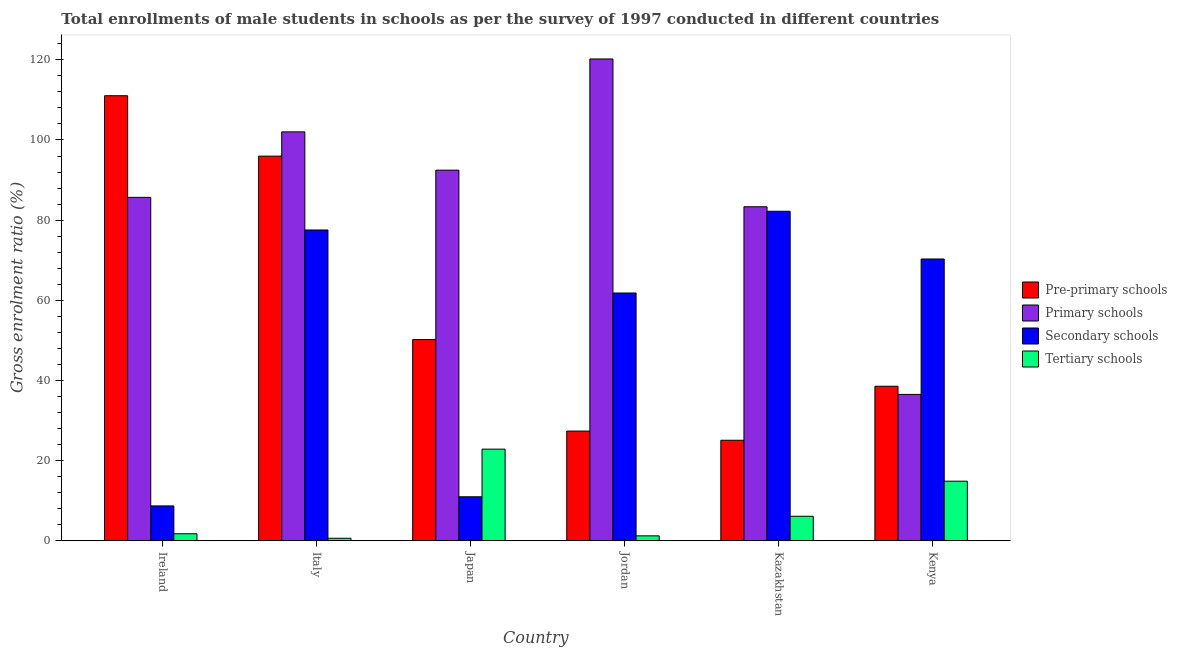How many different coloured bars are there?
Make the answer very short. 4. Are the number of bars on each tick of the X-axis equal?
Keep it short and to the point. Yes. How many bars are there on the 5th tick from the right?
Keep it short and to the point. 4. What is the label of the 2nd group of bars from the left?
Ensure brevity in your answer.  Italy. What is the gross enrolment ratio(male) in pre-primary schools in Italy?
Your answer should be compact. 95.97. Across all countries, what is the maximum gross enrolment ratio(male) in pre-primary schools?
Provide a short and direct response. 111.05. Across all countries, what is the minimum gross enrolment ratio(male) in secondary schools?
Ensure brevity in your answer.  8.69. In which country was the gross enrolment ratio(male) in primary schools maximum?
Provide a succinct answer. Jordan. What is the total gross enrolment ratio(male) in tertiary schools in the graph?
Keep it short and to the point. 47.38. What is the difference between the gross enrolment ratio(male) in primary schools in Japan and that in Kenya?
Offer a terse response. 55.96. What is the difference between the gross enrolment ratio(male) in primary schools in Kenya and the gross enrolment ratio(male) in tertiary schools in Kazakhstan?
Offer a very short reply. 30.41. What is the average gross enrolment ratio(male) in tertiary schools per country?
Your answer should be compact. 7.9. What is the difference between the gross enrolment ratio(male) in primary schools and gross enrolment ratio(male) in tertiary schools in Italy?
Keep it short and to the point. 101.41. In how many countries, is the gross enrolment ratio(male) in pre-primary schools greater than 84 %?
Give a very brief answer. 2. What is the ratio of the gross enrolment ratio(male) in primary schools in Japan to that in Jordan?
Provide a short and direct response. 0.77. Is the gross enrolment ratio(male) in pre-primary schools in Italy less than that in Kenya?
Keep it short and to the point. No. What is the difference between the highest and the second highest gross enrolment ratio(male) in tertiary schools?
Your answer should be compact. 8. What is the difference between the highest and the lowest gross enrolment ratio(male) in secondary schools?
Ensure brevity in your answer.  73.53. In how many countries, is the gross enrolment ratio(male) in primary schools greater than the average gross enrolment ratio(male) in primary schools taken over all countries?
Provide a short and direct response. 3. Is it the case that in every country, the sum of the gross enrolment ratio(male) in tertiary schools and gross enrolment ratio(male) in pre-primary schools is greater than the sum of gross enrolment ratio(male) in secondary schools and gross enrolment ratio(male) in primary schools?
Offer a terse response. No. What does the 2nd bar from the left in Kenya represents?
Ensure brevity in your answer.  Primary schools. What does the 2nd bar from the right in Japan represents?
Provide a succinct answer. Secondary schools. Are the values on the major ticks of Y-axis written in scientific E-notation?
Give a very brief answer. No. Does the graph contain any zero values?
Give a very brief answer. No. Does the graph contain grids?
Provide a succinct answer. No. What is the title of the graph?
Offer a very short reply. Total enrollments of male students in schools as per the survey of 1997 conducted in different countries. Does "Burnt food" appear as one of the legend labels in the graph?
Make the answer very short. No. What is the label or title of the X-axis?
Your answer should be very brief. Country. What is the Gross enrolment ratio (%) in Pre-primary schools in Ireland?
Offer a very short reply. 111.05. What is the Gross enrolment ratio (%) of Primary schools in Ireland?
Your answer should be very brief. 85.69. What is the Gross enrolment ratio (%) in Secondary schools in Ireland?
Provide a short and direct response. 8.69. What is the Gross enrolment ratio (%) of Tertiary schools in Ireland?
Make the answer very short. 1.74. What is the Gross enrolment ratio (%) of Pre-primary schools in Italy?
Ensure brevity in your answer.  95.97. What is the Gross enrolment ratio (%) of Primary schools in Italy?
Keep it short and to the point. 102.03. What is the Gross enrolment ratio (%) in Secondary schools in Italy?
Your response must be concise. 77.54. What is the Gross enrolment ratio (%) of Tertiary schools in Italy?
Your answer should be compact. 0.61. What is the Gross enrolment ratio (%) of Pre-primary schools in Japan?
Provide a succinct answer. 50.19. What is the Gross enrolment ratio (%) of Primary schools in Japan?
Ensure brevity in your answer.  92.47. What is the Gross enrolment ratio (%) of Secondary schools in Japan?
Your answer should be very brief. 10.97. What is the Gross enrolment ratio (%) of Tertiary schools in Japan?
Provide a succinct answer. 22.86. What is the Gross enrolment ratio (%) of Pre-primary schools in Jordan?
Keep it short and to the point. 27.36. What is the Gross enrolment ratio (%) in Primary schools in Jordan?
Provide a succinct answer. 120.22. What is the Gross enrolment ratio (%) in Secondary schools in Jordan?
Offer a terse response. 61.82. What is the Gross enrolment ratio (%) in Tertiary schools in Jordan?
Your answer should be compact. 1.21. What is the Gross enrolment ratio (%) in Pre-primary schools in Kazakhstan?
Offer a terse response. 25.07. What is the Gross enrolment ratio (%) of Primary schools in Kazakhstan?
Offer a terse response. 83.34. What is the Gross enrolment ratio (%) in Secondary schools in Kazakhstan?
Offer a very short reply. 82.22. What is the Gross enrolment ratio (%) of Tertiary schools in Kazakhstan?
Your answer should be very brief. 6.1. What is the Gross enrolment ratio (%) in Pre-primary schools in Kenya?
Your response must be concise. 38.55. What is the Gross enrolment ratio (%) of Primary schools in Kenya?
Your answer should be compact. 36.51. What is the Gross enrolment ratio (%) in Secondary schools in Kenya?
Provide a succinct answer. 70.31. What is the Gross enrolment ratio (%) of Tertiary schools in Kenya?
Keep it short and to the point. 14.85. Across all countries, what is the maximum Gross enrolment ratio (%) in Pre-primary schools?
Your answer should be compact. 111.05. Across all countries, what is the maximum Gross enrolment ratio (%) in Primary schools?
Make the answer very short. 120.22. Across all countries, what is the maximum Gross enrolment ratio (%) of Secondary schools?
Your answer should be very brief. 82.22. Across all countries, what is the maximum Gross enrolment ratio (%) in Tertiary schools?
Keep it short and to the point. 22.86. Across all countries, what is the minimum Gross enrolment ratio (%) in Pre-primary schools?
Offer a terse response. 25.07. Across all countries, what is the minimum Gross enrolment ratio (%) of Primary schools?
Give a very brief answer. 36.51. Across all countries, what is the minimum Gross enrolment ratio (%) of Secondary schools?
Provide a short and direct response. 8.69. Across all countries, what is the minimum Gross enrolment ratio (%) in Tertiary schools?
Your answer should be compact. 0.61. What is the total Gross enrolment ratio (%) of Pre-primary schools in the graph?
Provide a succinct answer. 348.2. What is the total Gross enrolment ratio (%) in Primary schools in the graph?
Provide a succinct answer. 520.26. What is the total Gross enrolment ratio (%) in Secondary schools in the graph?
Provide a succinct answer. 311.54. What is the total Gross enrolment ratio (%) of Tertiary schools in the graph?
Offer a very short reply. 47.38. What is the difference between the Gross enrolment ratio (%) of Pre-primary schools in Ireland and that in Italy?
Keep it short and to the point. 15.08. What is the difference between the Gross enrolment ratio (%) of Primary schools in Ireland and that in Italy?
Provide a short and direct response. -16.34. What is the difference between the Gross enrolment ratio (%) of Secondary schools in Ireland and that in Italy?
Keep it short and to the point. -68.86. What is the difference between the Gross enrolment ratio (%) in Tertiary schools in Ireland and that in Italy?
Give a very brief answer. 1.13. What is the difference between the Gross enrolment ratio (%) in Pre-primary schools in Ireland and that in Japan?
Provide a short and direct response. 60.86. What is the difference between the Gross enrolment ratio (%) in Primary schools in Ireland and that in Japan?
Give a very brief answer. -6.79. What is the difference between the Gross enrolment ratio (%) of Secondary schools in Ireland and that in Japan?
Keep it short and to the point. -2.28. What is the difference between the Gross enrolment ratio (%) of Tertiary schools in Ireland and that in Japan?
Ensure brevity in your answer.  -21.12. What is the difference between the Gross enrolment ratio (%) in Pre-primary schools in Ireland and that in Jordan?
Offer a terse response. 83.68. What is the difference between the Gross enrolment ratio (%) in Primary schools in Ireland and that in Jordan?
Your answer should be compact. -34.53. What is the difference between the Gross enrolment ratio (%) in Secondary schools in Ireland and that in Jordan?
Provide a succinct answer. -53.13. What is the difference between the Gross enrolment ratio (%) of Tertiary schools in Ireland and that in Jordan?
Provide a short and direct response. 0.53. What is the difference between the Gross enrolment ratio (%) in Pre-primary schools in Ireland and that in Kazakhstan?
Your response must be concise. 85.98. What is the difference between the Gross enrolment ratio (%) of Primary schools in Ireland and that in Kazakhstan?
Your answer should be very brief. 2.35. What is the difference between the Gross enrolment ratio (%) in Secondary schools in Ireland and that in Kazakhstan?
Make the answer very short. -73.53. What is the difference between the Gross enrolment ratio (%) of Tertiary schools in Ireland and that in Kazakhstan?
Give a very brief answer. -4.36. What is the difference between the Gross enrolment ratio (%) of Pre-primary schools in Ireland and that in Kenya?
Provide a short and direct response. 72.5. What is the difference between the Gross enrolment ratio (%) of Primary schools in Ireland and that in Kenya?
Ensure brevity in your answer.  49.18. What is the difference between the Gross enrolment ratio (%) in Secondary schools in Ireland and that in Kenya?
Ensure brevity in your answer.  -61.62. What is the difference between the Gross enrolment ratio (%) in Tertiary schools in Ireland and that in Kenya?
Your response must be concise. -13.11. What is the difference between the Gross enrolment ratio (%) in Pre-primary schools in Italy and that in Japan?
Offer a very short reply. 45.78. What is the difference between the Gross enrolment ratio (%) in Primary schools in Italy and that in Japan?
Give a very brief answer. 9.55. What is the difference between the Gross enrolment ratio (%) of Secondary schools in Italy and that in Japan?
Keep it short and to the point. 66.58. What is the difference between the Gross enrolment ratio (%) of Tertiary schools in Italy and that in Japan?
Offer a terse response. -22.24. What is the difference between the Gross enrolment ratio (%) in Pre-primary schools in Italy and that in Jordan?
Make the answer very short. 68.61. What is the difference between the Gross enrolment ratio (%) of Primary schools in Italy and that in Jordan?
Provide a succinct answer. -18.19. What is the difference between the Gross enrolment ratio (%) of Secondary schools in Italy and that in Jordan?
Offer a terse response. 15.73. What is the difference between the Gross enrolment ratio (%) in Tertiary schools in Italy and that in Jordan?
Ensure brevity in your answer.  -0.6. What is the difference between the Gross enrolment ratio (%) of Pre-primary schools in Italy and that in Kazakhstan?
Keep it short and to the point. 70.9. What is the difference between the Gross enrolment ratio (%) of Primary schools in Italy and that in Kazakhstan?
Ensure brevity in your answer.  18.69. What is the difference between the Gross enrolment ratio (%) in Secondary schools in Italy and that in Kazakhstan?
Keep it short and to the point. -4.67. What is the difference between the Gross enrolment ratio (%) in Tertiary schools in Italy and that in Kazakhstan?
Keep it short and to the point. -5.49. What is the difference between the Gross enrolment ratio (%) in Pre-primary schools in Italy and that in Kenya?
Keep it short and to the point. 57.42. What is the difference between the Gross enrolment ratio (%) of Primary schools in Italy and that in Kenya?
Ensure brevity in your answer.  65.52. What is the difference between the Gross enrolment ratio (%) of Secondary schools in Italy and that in Kenya?
Your answer should be very brief. 7.24. What is the difference between the Gross enrolment ratio (%) in Tertiary schools in Italy and that in Kenya?
Make the answer very short. -14.24. What is the difference between the Gross enrolment ratio (%) in Pre-primary schools in Japan and that in Jordan?
Provide a short and direct response. 22.83. What is the difference between the Gross enrolment ratio (%) of Primary schools in Japan and that in Jordan?
Offer a very short reply. -27.75. What is the difference between the Gross enrolment ratio (%) of Secondary schools in Japan and that in Jordan?
Your answer should be compact. -50.85. What is the difference between the Gross enrolment ratio (%) of Tertiary schools in Japan and that in Jordan?
Offer a terse response. 21.64. What is the difference between the Gross enrolment ratio (%) of Pre-primary schools in Japan and that in Kazakhstan?
Give a very brief answer. 25.12. What is the difference between the Gross enrolment ratio (%) of Primary schools in Japan and that in Kazakhstan?
Your answer should be very brief. 9.13. What is the difference between the Gross enrolment ratio (%) in Secondary schools in Japan and that in Kazakhstan?
Provide a short and direct response. -71.25. What is the difference between the Gross enrolment ratio (%) of Tertiary schools in Japan and that in Kazakhstan?
Your answer should be very brief. 16.75. What is the difference between the Gross enrolment ratio (%) of Pre-primary schools in Japan and that in Kenya?
Make the answer very short. 11.64. What is the difference between the Gross enrolment ratio (%) in Primary schools in Japan and that in Kenya?
Provide a short and direct response. 55.96. What is the difference between the Gross enrolment ratio (%) of Secondary schools in Japan and that in Kenya?
Your response must be concise. -59.34. What is the difference between the Gross enrolment ratio (%) of Tertiary schools in Japan and that in Kenya?
Your answer should be compact. 8. What is the difference between the Gross enrolment ratio (%) of Pre-primary schools in Jordan and that in Kazakhstan?
Your response must be concise. 2.29. What is the difference between the Gross enrolment ratio (%) in Primary schools in Jordan and that in Kazakhstan?
Your response must be concise. 36.88. What is the difference between the Gross enrolment ratio (%) in Secondary schools in Jordan and that in Kazakhstan?
Keep it short and to the point. -20.4. What is the difference between the Gross enrolment ratio (%) in Tertiary schools in Jordan and that in Kazakhstan?
Your answer should be very brief. -4.89. What is the difference between the Gross enrolment ratio (%) in Pre-primary schools in Jordan and that in Kenya?
Provide a short and direct response. -11.18. What is the difference between the Gross enrolment ratio (%) of Primary schools in Jordan and that in Kenya?
Provide a short and direct response. 83.71. What is the difference between the Gross enrolment ratio (%) in Secondary schools in Jordan and that in Kenya?
Provide a succinct answer. -8.49. What is the difference between the Gross enrolment ratio (%) in Tertiary schools in Jordan and that in Kenya?
Give a very brief answer. -13.64. What is the difference between the Gross enrolment ratio (%) in Pre-primary schools in Kazakhstan and that in Kenya?
Provide a succinct answer. -13.48. What is the difference between the Gross enrolment ratio (%) in Primary schools in Kazakhstan and that in Kenya?
Provide a succinct answer. 46.83. What is the difference between the Gross enrolment ratio (%) in Secondary schools in Kazakhstan and that in Kenya?
Offer a very short reply. 11.91. What is the difference between the Gross enrolment ratio (%) in Tertiary schools in Kazakhstan and that in Kenya?
Provide a short and direct response. -8.75. What is the difference between the Gross enrolment ratio (%) in Pre-primary schools in Ireland and the Gross enrolment ratio (%) in Primary schools in Italy?
Your answer should be very brief. 9.02. What is the difference between the Gross enrolment ratio (%) of Pre-primary schools in Ireland and the Gross enrolment ratio (%) of Secondary schools in Italy?
Keep it short and to the point. 33.51. What is the difference between the Gross enrolment ratio (%) of Pre-primary schools in Ireland and the Gross enrolment ratio (%) of Tertiary schools in Italy?
Offer a terse response. 110.44. What is the difference between the Gross enrolment ratio (%) of Primary schools in Ireland and the Gross enrolment ratio (%) of Secondary schools in Italy?
Provide a succinct answer. 8.14. What is the difference between the Gross enrolment ratio (%) of Primary schools in Ireland and the Gross enrolment ratio (%) of Tertiary schools in Italy?
Your response must be concise. 85.07. What is the difference between the Gross enrolment ratio (%) of Secondary schools in Ireland and the Gross enrolment ratio (%) of Tertiary schools in Italy?
Ensure brevity in your answer.  8.07. What is the difference between the Gross enrolment ratio (%) in Pre-primary schools in Ireland and the Gross enrolment ratio (%) in Primary schools in Japan?
Your response must be concise. 18.58. What is the difference between the Gross enrolment ratio (%) in Pre-primary schools in Ireland and the Gross enrolment ratio (%) in Secondary schools in Japan?
Ensure brevity in your answer.  100.08. What is the difference between the Gross enrolment ratio (%) of Pre-primary schools in Ireland and the Gross enrolment ratio (%) of Tertiary schools in Japan?
Your answer should be very brief. 88.19. What is the difference between the Gross enrolment ratio (%) in Primary schools in Ireland and the Gross enrolment ratio (%) in Secondary schools in Japan?
Make the answer very short. 74.72. What is the difference between the Gross enrolment ratio (%) in Primary schools in Ireland and the Gross enrolment ratio (%) in Tertiary schools in Japan?
Your response must be concise. 62.83. What is the difference between the Gross enrolment ratio (%) in Secondary schools in Ireland and the Gross enrolment ratio (%) in Tertiary schools in Japan?
Provide a short and direct response. -14.17. What is the difference between the Gross enrolment ratio (%) of Pre-primary schools in Ireland and the Gross enrolment ratio (%) of Primary schools in Jordan?
Provide a succinct answer. -9.17. What is the difference between the Gross enrolment ratio (%) in Pre-primary schools in Ireland and the Gross enrolment ratio (%) in Secondary schools in Jordan?
Provide a short and direct response. 49.23. What is the difference between the Gross enrolment ratio (%) of Pre-primary schools in Ireland and the Gross enrolment ratio (%) of Tertiary schools in Jordan?
Make the answer very short. 109.83. What is the difference between the Gross enrolment ratio (%) of Primary schools in Ireland and the Gross enrolment ratio (%) of Secondary schools in Jordan?
Provide a succinct answer. 23.87. What is the difference between the Gross enrolment ratio (%) in Primary schools in Ireland and the Gross enrolment ratio (%) in Tertiary schools in Jordan?
Make the answer very short. 84.47. What is the difference between the Gross enrolment ratio (%) in Secondary schools in Ireland and the Gross enrolment ratio (%) in Tertiary schools in Jordan?
Provide a short and direct response. 7.47. What is the difference between the Gross enrolment ratio (%) in Pre-primary schools in Ireland and the Gross enrolment ratio (%) in Primary schools in Kazakhstan?
Provide a succinct answer. 27.71. What is the difference between the Gross enrolment ratio (%) in Pre-primary schools in Ireland and the Gross enrolment ratio (%) in Secondary schools in Kazakhstan?
Provide a short and direct response. 28.83. What is the difference between the Gross enrolment ratio (%) in Pre-primary schools in Ireland and the Gross enrolment ratio (%) in Tertiary schools in Kazakhstan?
Offer a terse response. 104.95. What is the difference between the Gross enrolment ratio (%) in Primary schools in Ireland and the Gross enrolment ratio (%) in Secondary schools in Kazakhstan?
Your answer should be compact. 3.47. What is the difference between the Gross enrolment ratio (%) of Primary schools in Ireland and the Gross enrolment ratio (%) of Tertiary schools in Kazakhstan?
Provide a succinct answer. 79.58. What is the difference between the Gross enrolment ratio (%) of Secondary schools in Ireland and the Gross enrolment ratio (%) of Tertiary schools in Kazakhstan?
Give a very brief answer. 2.58. What is the difference between the Gross enrolment ratio (%) of Pre-primary schools in Ireland and the Gross enrolment ratio (%) of Primary schools in Kenya?
Offer a terse response. 74.54. What is the difference between the Gross enrolment ratio (%) of Pre-primary schools in Ireland and the Gross enrolment ratio (%) of Secondary schools in Kenya?
Keep it short and to the point. 40.74. What is the difference between the Gross enrolment ratio (%) of Pre-primary schools in Ireland and the Gross enrolment ratio (%) of Tertiary schools in Kenya?
Keep it short and to the point. 96.2. What is the difference between the Gross enrolment ratio (%) of Primary schools in Ireland and the Gross enrolment ratio (%) of Secondary schools in Kenya?
Give a very brief answer. 15.38. What is the difference between the Gross enrolment ratio (%) in Primary schools in Ireland and the Gross enrolment ratio (%) in Tertiary schools in Kenya?
Ensure brevity in your answer.  70.84. What is the difference between the Gross enrolment ratio (%) of Secondary schools in Ireland and the Gross enrolment ratio (%) of Tertiary schools in Kenya?
Your answer should be compact. -6.17. What is the difference between the Gross enrolment ratio (%) in Pre-primary schools in Italy and the Gross enrolment ratio (%) in Primary schools in Japan?
Offer a very short reply. 3.5. What is the difference between the Gross enrolment ratio (%) of Pre-primary schools in Italy and the Gross enrolment ratio (%) of Secondary schools in Japan?
Keep it short and to the point. 85.01. What is the difference between the Gross enrolment ratio (%) of Pre-primary schools in Italy and the Gross enrolment ratio (%) of Tertiary schools in Japan?
Provide a succinct answer. 73.12. What is the difference between the Gross enrolment ratio (%) in Primary schools in Italy and the Gross enrolment ratio (%) in Secondary schools in Japan?
Give a very brief answer. 91.06. What is the difference between the Gross enrolment ratio (%) of Primary schools in Italy and the Gross enrolment ratio (%) of Tertiary schools in Japan?
Offer a very short reply. 79.17. What is the difference between the Gross enrolment ratio (%) in Secondary schools in Italy and the Gross enrolment ratio (%) in Tertiary schools in Japan?
Offer a terse response. 54.69. What is the difference between the Gross enrolment ratio (%) in Pre-primary schools in Italy and the Gross enrolment ratio (%) in Primary schools in Jordan?
Ensure brevity in your answer.  -24.25. What is the difference between the Gross enrolment ratio (%) of Pre-primary schools in Italy and the Gross enrolment ratio (%) of Secondary schools in Jordan?
Keep it short and to the point. 34.16. What is the difference between the Gross enrolment ratio (%) in Pre-primary schools in Italy and the Gross enrolment ratio (%) in Tertiary schools in Jordan?
Give a very brief answer. 94.76. What is the difference between the Gross enrolment ratio (%) of Primary schools in Italy and the Gross enrolment ratio (%) of Secondary schools in Jordan?
Offer a very short reply. 40.21. What is the difference between the Gross enrolment ratio (%) of Primary schools in Italy and the Gross enrolment ratio (%) of Tertiary schools in Jordan?
Make the answer very short. 100.81. What is the difference between the Gross enrolment ratio (%) of Secondary schools in Italy and the Gross enrolment ratio (%) of Tertiary schools in Jordan?
Your response must be concise. 76.33. What is the difference between the Gross enrolment ratio (%) of Pre-primary schools in Italy and the Gross enrolment ratio (%) of Primary schools in Kazakhstan?
Give a very brief answer. 12.63. What is the difference between the Gross enrolment ratio (%) of Pre-primary schools in Italy and the Gross enrolment ratio (%) of Secondary schools in Kazakhstan?
Your response must be concise. 13.76. What is the difference between the Gross enrolment ratio (%) in Pre-primary schools in Italy and the Gross enrolment ratio (%) in Tertiary schools in Kazakhstan?
Provide a succinct answer. 89.87. What is the difference between the Gross enrolment ratio (%) of Primary schools in Italy and the Gross enrolment ratio (%) of Secondary schools in Kazakhstan?
Provide a short and direct response. 19.81. What is the difference between the Gross enrolment ratio (%) in Primary schools in Italy and the Gross enrolment ratio (%) in Tertiary schools in Kazakhstan?
Give a very brief answer. 95.92. What is the difference between the Gross enrolment ratio (%) of Secondary schools in Italy and the Gross enrolment ratio (%) of Tertiary schools in Kazakhstan?
Make the answer very short. 71.44. What is the difference between the Gross enrolment ratio (%) in Pre-primary schools in Italy and the Gross enrolment ratio (%) in Primary schools in Kenya?
Offer a terse response. 59.46. What is the difference between the Gross enrolment ratio (%) in Pre-primary schools in Italy and the Gross enrolment ratio (%) in Secondary schools in Kenya?
Keep it short and to the point. 25.67. What is the difference between the Gross enrolment ratio (%) in Pre-primary schools in Italy and the Gross enrolment ratio (%) in Tertiary schools in Kenya?
Offer a very short reply. 81.12. What is the difference between the Gross enrolment ratio (%) of Primary schools in Italy and the Gross enrolment ratio (%) of Secondary schools in Kenya?
Offer a very short reply. 31.72. What is the difference between the Gross enrolment ratio (%) of Primary schools in Italy and the Gross enrolment ratio (%) of Tertiary schools in Kenya?
Keep it short and to the point. 87.18. What is the difference between the Gross enrolment ratio (%) in Secondary schools in Italy and the Gross enrolment ratio (%) in Tertiary schools in Kenya?
Your answer should be very brief. 62.69. What is the difference between the Gross enrolment ratio (%) of Pre-primary schools in Japan and the Gross enrolment ratio (%) of Primary schools in Jordan?
Keep it short and to the point. -70.03. What is the difference between the Gross enrolment ratio (%) of Pre-primary schools in Japan and the Gross enrolment ratio (%) of Secondary schools in Jordan?
Your response must be concise. -11.62. What is the difference between the Gross enrolment ratio (%) in Pre-primary schools in Japan and the Gross enrolment ratio (%) in Tertiary schools in Jordan?
Offer a very short reply. 48.98. What is the difference between the Gross enrolment ratio (%) in Primary schools in Japan and the Gross enrolment ratio (%) in Secondary schools in Jordan?
Make the answer very short. 30.66. What is the difference between the Gross enrolment ratio (%) of Primary schools in Japan and the Gross enrolment ratio (%) of Tertiary schools in Jordan?
Provide a short and direct response. 91.26. What is the difference between the Gross enrolment ratio (%) of Secondary schools in Japan and the Gross enrolment ratio (%) of Tertiary schools in Jordan?
Offer a terse response. 9.75. What is the difference between the Gross enrolment ratio (%) of Pre-primary schools in Japan and the Gross enrolment ratio (%) of Primary schools in Kazakhstan?
Offer a terse response. -33.15. What is the difference between the Gross enrolment ratio (%) of Pre-primary schools in Japan and the Gross enrolment ratio (%) of Secondary schools in Kazakhstan?
Offer a very short reply. -32.03. What is the difference between the Gross enrolment ratio (%) in Pre-primary schools in Japan and the Gross enrolment ratio (%) in Tertiary schools in Kazakhstan?
Ensure brevity in your answer.  44.09. What is the difference between the Gross enrolment ratio (%) of Primary schools in Japan and the Gross enrolment ratio (%) of Secondary schools in Kazakhstan?
Keep it short and to the point. 10.26. What is the difference between the Gross enrolment ratio (%) of Primary schools in Japan and the Gross enrolment ratio (%) of Tertiary schools in Kazakhstan?
Make the answer very short. 86.37. What is the difference between the Gross enrolment ratio (%) in Secondary schools in Japan and the Gross enrolment ratio (%) in Tertiary schools in Kazakhstan?
Provide a short and direct response. 4.86. What is the difference between the Gross enrolment ratio (%) in Pre-primary schools in Japan and the Gross enrolment ratio (%) in Primary schools in Kenya?
Your answer should be compact. 13.68. What is the difference between the Gross enrolment ratio (%) of Pre-primary schools in Japan and the Gross enrolment ratio (%) of Secondary schools in Kenya?
Your response must be concise. -20.11. What is the difference between the Gross enrolment ratio (%) in Pre-primary schools in Japan and the Gross enrolment ratio (%) in Tertiary schools in Kenya?
Make the answer very short. 35.34. What is the difference between the Gross enrolment ratio (%) of Primary schools in Japan and the Gross enrolment ratio (%) of Secondary schools in Kenya?
Make the answer very short. 22.17. What is the difference between the Gross enrolment ratio (%) in Primary schools in Japan and the Gross enrolment ratio (%) in Tertiary schools in Kenya?
Make the answer very short. 77.62. What is the difference between the Gross enrolment ratio (%) of Secondary schools in Japan and the Gross enrolment ratio (%) of Tertiary schools in Kenya?
Your answer should be compact. -3.89. What is the difference between the Gross enrolment ratio (%) of Pre-primary schools in Jordan and the Gross enrolment ratio (%) of Primary schools in Kazakhstan?
Give a very brief answer. -55.98. What is the difference between the Gross enrolment ratio (%) of Pre-primary schools in Jordan and the Gross enrolment ratio (%) of Secondary schools in Kazakhstan?
Your response must be concise. -54.85. What is the difference between the Gross enrolment ratio (%) in Pre-primary schools in Jordan and the Gross enrolment ratio (%) in Tertiary schools in Kazakhstan?
Your answer should be very brief. 21.26. What is the difference between the Gross enrolment ratio (%) of Primary schools in Jordan and the Gross enrolment ratio (%) of Secondary schools in Kazakhstan?
Give a very brief answer. 38.01. What is the difference between the Gross enrolment ratio (%) in Primary schools in Jordan and the Gross enrolment ratio (%) in Tertiary schools in Kazakhstan?
Provide a succinct answer. 114.12. What is the difference between the Gross enrolment ratio (%) of Secondary schools in Jordan and the Gross enrolment ratio (%) of Tertiary schools in Kazakhstan?
Your answer should be compact. 55.71. What is the difference between the Gross enrolment ratio (%) of Pre-primary schools in Jordan and the Gross enrolment ratio (%) of Primary schools in Kenya?
Give a very brief answer. -9.15. What is the difference between the Gross enrolment ratio (%) of Pre-primary schools in Jordan and the Gross enrolment ratio (%) of Secondary schools in Kenya?
Give a very brief answer. -42.94. What is the difference between the Gross enrolment ratio (%) in Pre-primary schools in Jordan and the Gross enrolment ratio (%) in Tertiary schools in Kenya?
Keep it short and to the point. 12.51. What is the difference between the Gross enrolment ratio (%) of Primary schools in Jordan and the Gross enrolment ratio (%) of Secondary schools in Kenya?
Give a very brief answer. 49.92. What is the difference between the Gross enrolment ratio (%) of Primary schools in Jordan and the Gross enrolment ratio (%) of Tertiary schools in Kenya?
Offer a terse response. 105.37. What is the difference between the Gross enrolment ratio (%) of Secondary schools in Jordan and the Gross enrolment ratio (%) of Tertiary schools in Kenya?
Provide a succinct answer. 46.96. What is the difference between the Gross enrolment ratio (%) in Pre-primary schools in Kazakhstan and the Gross enrolment ratio (%) in Primary schools in Kenya?
Provide a short and direct response. -11.44. What is the difference between the Gross enrolment ratio (%) of Pre-primary schools in Kazakhstan and the Gross enrolment ratio (%) of Secondary schools in Kenya?
Make the answer very short. -45.23. What is the difference between the Gross enrolment ratio (%) of Pre-primary schools in Kazakhstan and the Gross enrolment ratio (%) of Tertiary schools in Kenya?
Keep it short and to the point. 10.22. What is the difference between the Gross enrolment ratio (%) of Primary schools in Kazakhstan and the Gross enrolment ratio (%) of Secondary schools in Kenya?
Ensure brevity in your answer.  13.04. What is the difference between the Gross enrolment ratio (%) of Primary schools in Kazakhstan and the Gross enrolment ratio (%) of Tertiary schools in Kenya?
Provide a succinct answer. 68.49. What is the difference between the Gross enrolment ratio (%) of Secondary schools in Kazakhstan and the Gross enrolment ratio (%) of Tertiary schools in Kenya?
Your response must be concise. 67.36. What is the average Gross enrolment ratio (%) of Pre-primary schools per country?
Ensure brevity in your answer.  58.03. What is the average Gross enrolment ratio (%) in Primary schools per country?
Give a very brief answer. 86.71. What is the average Gross enrolment ratio (%) of Secondary schools per country?
Ensure brevity in your answer.  51.92. What is the average Gross enrolment ratio (%) of Tertiary schools per country?
Your response must be concise. 7.9. What is the difference between the Gross enrolment ratio (%) in Pre-primary schools and Gross enrolment ratio (%) in Primary schools in Ireland?
Give a very brief answer. 25.36. What is the difference between the Gross enrolment ratio (%) in Pre-primary schools and Gross enrolment ratio (%) in Secondary schools in Ireland?
Make the answer very short. 102.36. What is the difference between the Gross enrolment ratio (%) in Pre-primary schools and Gross enrolment ratio (%) in Tertiary schools in Ireland?
Make the answer very short. 109.31. What is the difference between the Gross enrolment ratio (%) in Primary schools and Gross enrolment ratio (%) in Secondary schools in Ireland?
Make the answer very short. 77. What is the difference between the Gross enrolment ratio (%) in Primary schools and Gross enrolment ratio (%) in Tertiary schools in Ireland?
Your answer should be compact. 83.95. What is the difference between the Gross enrolment ratio (%) in Secondary schools and Gross enrolment ratio (%) in Tertiary schools in Ireland?
Make the answer very short. 6.95. What is the difference between the Gross enrolment ratio (%) in Pre-primary schools and Gross enrolment ratio (%) in Primary schools in Italy?
Ensure brevity in your answer.  -6.05. What is the difference between the Gross enrolment ratio (%) of Pre-primary schools and Gross enrolment ratio (%) of Secondary schools in Italy?
Provide a short and direct response. 18.43. What is the difference between the Gross enrolment ratio (%) in Pre-primary schools and Gross enrolment ratio (%) in Tertiary schools in Italy?
Your response must be concise. 95.36. What is the difference between the Gross enrolment ratio (%) in Primary schools and Gross enrolment ratio (%) in Secondary schools in Italy?
Make the answer very short. 24.48. What is the difference between the Gross enrolment ratio (%) in Primary schools and Gross enrolment ratio (%) in Tertiary schools in Italy?
Provide a short and direct response. 101.41. What is the difference between the Gross enrolment ratio (%) in Secondary schools and Gross enrolment ratio (%) in Tertiary schools in Italy?
Your answer should be very brief. 76.93. What is the difference between the Gross enrolment ratio (%) of Pre-primary schools and Gross enrolment ratio (%) of Primary schools in Japan?
Offer a terse response. -42.28. What is the difference between the Gross enrolment ratio (%) of Pre-primary schools and Gross enrolment ratio (%) of Secondary schools in Japan?
Provide a succinct answer. 39.22. What is the difference between the Gross enrolment ratio (%) in Pre-primary schools and Gross enrolment ratio (%) in Tertiary schools in Japan?
Offer a terse response. 27.34. What is the difference between the Gross enrolment ratio (%) of Primary schools and Gross enrolment ratio (%) of Secondary schools in Japan?
Provide a succinct answer. 81.51. What is the difference between the Gross enrolment ratio (%) of Primary schools and Gross enrolment ratio (%) of Tertiary schools in Japan?
Offer a terse response. 69.62. What is the difference between the Gross enrolment ratio (%) of Secondary schools and Gross enrolment ratio (%) of Tertiary schools in Japan?
Your answer should be very brief. -11.89. What is the difference between the Gross enrolment ratio (%) in Pre-primary schools and Gross enrolment ratio (%) in Primary schools in Jordan?
Your answer should be very brief. -92.86. What is the difference between the Gross enrolment ratio (%) of Pre-primary schools and Gross enrolment ratio (%) of Secondary schools in Jordan?
Provide a succinct answer. -34.45. What is the difference between the Gross enrolment ratio (%) of Pre-primary schools and Gross enrolment ratio (%) of Tertiary schools in Jordan?
Offer a very short reply. 26.15. What is the difference between the Gross enrolment ratio (%) of Primary schools and Gross enrolment ratio (%) of Secondary schools in Jordan?
Provide a succinct answer. 58.41. What is the difference between the Gross enrolment ratio (%) of Primary schools and Gross enrolment ratio (%) of Tertiary schools in Jordan?
Provide a succinct answer. 119.01. What is the difference between the Gross enrolment ratio (%) of Secondary schools and Gross enrolment ratio (%) of Tertiary schools in Jordan?
Your response must be concise. 60.6. What is the difference between the Gross enrolment ratio (%) of Pre-primary schools and Gross enrolment ratio (%) of Primary schools in Kazakhstan?
Provide a succinct answer. -58.27. What is the difference between the Gross enrolment ratio (%) in Pre-primary schools and Gross enrolment ratio (%) in Secondary schools in Kazakhstan?
Give a very brief answer. -57.15. What is the difference between the Gross enrolment ratio (%) in Pre-primary schools and Gross enrolment ratio (%) in Tertiary schools in Kazakhstan?
Your answer should be very brief. 18.97. What is the difference between the Gross enrolment ratio (%) in Primary schools and Gross enrolment ratio (%) in Secondary schools in Kazakhstan?
Your answer should be compact. 1.13. What is the difference between the Gross enrolment ratio (%) in Primary schools and Gross enrolment ratio (%) in Tertiary schools in Kazakhstan?
Ensure brevity in your answer.  77.24. What is the difference between the Gross enrolment ratio (%) of Secondary schools and Gross enrolment ratio (%) of Tertiary schools in Kazakhstan?
Offer a terse response. 76.11. What is the difference between the Gross enrolment ratio (%) in Pre-primary schools and Gross enrolment ratio (%) in Primary schools in Kenya?
Offer a terse response. 2.04. What is the difference between the Gross enrolment ratio (%) in Pre-primary schools and Gross enrolment ratio (%) in Secondary schools in Kenya?
Your answer should be very brief. -31.76. What is the difference between the Gross enrolment ratio (%) in Pre-primary schools and Gross enrolment ratio (%) in Tertiary schools in Kenya?
Offer a very short reply. 23.7. What is the difference between the Gross enrolment ratio (%) in Primary schools and Gross enrolment ratio (%) in Secondary schools in Kenya?
Ensure brevity in your answer.  -33.8. What is the difference between the Gross enrolment ratio (%) in Primary schools and Gross enrolment ratio (%) in Tertiary schools in Kenya?
Your answer should be very brief. 21.66. What is the difference between the Gross enrolment ratio (%) in Secondary schools and Gross enrolment ratio (%) in Tertiary schools in Kenya?
Your response must be concise. 55.45. What is the ratio of the Gross enrolment ratio (%) of Pre-primary schools in Ireland to that in Italy?
Ensure brevity in your answer.  1.16. What is the ratio of the Gross enrolment ratio (%) in Primary schools in Ireland to that in Italy?
Offer a very short reply. 0.84. What is the ratio of the Gross enrolment ratio (%) in Secondary schools in Ireland to that in Italy?
Your answer should be very brief. 0.11. What is the ratio of the Gross enrolment ratio (%) of Tertiary schools in Ireland to that in Italy?
Offer a very short reply. 2.84. What is the ratio of the Gross enrolment ratio (%) of Pre-primary schools in Ireland to that in Japan?
Provide a short and direct response. 2.21. What is the ratio of the Gross enrolment ratio (%) of Primary schools in Ireland to that in Japan?
Give a very brief answer. 0.93. What is the ratio of the Gross enrolment ratio (%) of Secondary schools in Ireland to that in Japan?
Keep it short and to the point. 0.79. What is the ratio of the Gross enrolment ratio (%) in Tertiary schools in Ireland to that in Japan?
Your answer should be compact. 0.08. What is the ratio of the Gross enrolment ratio (%) in Pre-primary schools in Ireland to that in Jordan?
Give a very brief answer. 4.06. What is the ratio of the Gross enrolment ratio (%) in Primary schools in Ireland to that in Jordan?
Ensure brevity in your answer.  0.71. What is the ratio of the Gross enrolment ratio (%) of Secondary schools in Ireland to that in Jordan?
Provide a short and direct response. 0.14. What is the ratio of the Gross enrolment ratio (%) in Tertiary schools in Ireland to that in Jordan?
Give a very brief answer. 1.43. What is the ratio of the Gross enrolment ratio (%) of Pre-primary schools in Ireland to that in Kazakhstan?
Offer a very short reply. 4.43. What is the ratio of the Gross enrolment ratio (%) of Primary schools in Ireland to that in Kazakhstan?
Your response must be concise. 1.03. What is the ratio of the Gross enrolment ratio (%) in Secondary schools in Ireland to that in Kazakhstan?
Ensure brevity in your answer.  0.11. What is the ratio of the Gross enrolment ratio (%) of Tertiary schools in Ireland to that in Kazakhstan?
Ensure brevity in your answer.  0.29. What is the ratio of the Gross enrolment ratio (%) of Pre-primary schools in Ireland to that in Kenya?
Ensure brevity in your answer.  2.88. What is the ratio of the Gross enrolment ratio (%) in Primary schools in Ireland to that in Kenya?
Keep it short and to the point. 2.35. What is the ratio of the Gross enrolment ratio (%) of Secondary schools in Ireland to that in Kenya?
Ensure brevity in your answer.  0.12. What is the ratio of the Gross enrolment ratio (%) of Tertiary schools in Ireland to that in Kenya?
Ensure brevity in your answer.  0.12. What is the ratio of the Gross enrolment ratio (%) of Pre-primary schools in Italy to that in Japan?
Offer a very short reply. 1.91. What is the ratio of the Gross enrolment ratio (%) in Primary schools in Italy to that in Japan?
Ensure brevity in your answer.  1.1. What is the ratio of the Gross enrolment ratio (%) in Secondary schools in Italy to that in Japan?
Provide a short and direct response. 7.07. What is the ratio of the Gross enrolment ratio (%) of Tertiary schools in Italy to that in Japan?
Your answer should be very brief. 0.03. What is the ratio of the Gross enrolment ratio (%) of Pre-primary schools in Italy to that in Jordan?
Offer a terse response. 3.51. What is the ratio of the Gross enrolment ratio (%) in Primary schools in Italy to that in Jordan?
Your answer should be compact. 0.85. What is the ratio of the Gross enrolment ratio (%) in Secondary schools in Italy to that in Jordan?
Your response must be concise. 1.25. What is the ratio of the Gross enrolment ratio (%) of Tertiary schools in Italy to that in Jordan?
Your answer should be very brief. 0.51. What is the ratio of the Gross enrolment ratio (%) of Pre-primary schools in Italy to that in Kazakhstan?
Keep it short and to the point. 3.83. What is the ratio of the Gross enrolment ratio (%) of Primary schools in Italy to that in Kazakhstan?
Give a very brief answer. 1.22. What is the ratio of the Gross enrolment ratio (%) of Secondary schools in Italy to that in Kazakhstan?
Provide a short and direct response. 0.94. What is the ratio of the Gross enrolment ratio (%) of Tertiary schools in Italy to that in Kazakhstan?
Ensure brevity in your answer.  0.1. What is the ratio of the Gross enrolment ratio (%) of Pre-primary schools in Italy to that in Kenya?
Give a very brief answer. 2.49. What is the ratio of the Gross enrolment ratio (%) of Primary schools in Italy to that in Kenya?
Provide a short and direct response. 2.79. What is the ratio of the Gross enrolment ratio (%) in Secondary schools in Italy to that in Kenya?
Keep it short and to the point. 1.1. What is the ratio of the Gross enrolment ratio (%) of Tertiary schools in Italy to that in Kenya?
Make the answer very short. 0.04. What is the ratio of the Gross enrolment ratio (%) of Pre-primary schools in Japan to that in Jordan?
Provide a short and direct response. 1.83. What is the ratio of the Gross enrolment ratio (%) of Primary schools in Japan to that in Jordan?
Keep it short and to the point. 0.77. What is the ratio of the Gross enrolment ratio (%) of Secondary schools in Japan to that in Jordan?
Your response must be concise. 0.18. What is the ratio of the Gross enrolment ratio (%) in Tertiary schools in Japan to that in Jordan?
Your answer should be very brief. 18.81. What is the ratio of the Gross enrolment ratio (%) of Pre-primary schools in Japan to that in Kazakhstan?
Offer a very short reply. 2. What is the ratio of the Gross enrolment ratio (%) in Primary schools in Japan to that in Kazakhstan?
Give a very brief answer. 1.11. What is the ratio of the Gross enrolment ratio (%) of Secondary schools in Japan to that in Kazakhstan?
Offer a terse response. 0.13. What is the ratio of the Gross enrolment ratio (%) in Tertiary schools in Japan to that in Kazakhstan?
Offer a very short reply. 3.74. What is the ratio of the Gross enrolment ratio (%) of Pre-primary schools in Japan to that in Kenya?
Ensure brevity in your answer.  1.3. What is the ratio of the Gross enrolment ratio (%) in Primary schools in Japan to that in Kenya?
Make the answer very short. 2.53. What is the ratio of the Gross enrolment ratio (%) in Secondary schools in Japan to that in Kenya?
Give a very brief answer. 0.16. What is the ratio of the Gross enrolment ratio (%) in Tertiary schools in Japan to that in Kenya?
Your answer should be compact. 1.54. What is the ratio of the Gross enrolment ratio (%) of Pre-primary schools in Jordan to that in Kazakhstan?
Make the answer very short. 1.09. What is the ratio of the Gross enrolment ratio (%) in Primary schools in Jordan to that in Kazakhstan?
Your response must be concise. 1.44. What is the ratio of the Gross enrolment ratio (%) of Secondary schools in Jordan to that in Kazakhstan?
Offer a very short reply. 0.75. What is the ratio of the Gross enrolment ratio (%) in Tertiary schools in Jordan to that in Kazakhstan?
Make the answer very short. 0.2. What is the ratio of the Gross enrolment ratio (%) of Pre-primary schools in Jordan to that in Kenya?
Give a very brief answer. 0.71. What is the ratio of the Gross enrolment ratio (%) in Primary schools in Jordan to that in Kenya?
Your answer should be compact. 3.29. What is the ratio of the Gross enrolment ratio (%) in Secondary schools in Jordan to that in Kenya?
Your answer should be very brief. 0.88. What is the ratio of the Gross enrolment ratio (%) in Tertiary schools in Jordan to that in Kenya?
Your response must be concise. 0.08. What is the ratio of the Gross enrolment ratio (%) of Pre-primary schools in Kazakhstan to that in Kenya?
Your answer should be compact. 0.65. What is the ratio of the Gross enrolment ratio (%) of Primary schools in Kazakhstan to that in Kenya?
Offer a terse response. 2.28. What is the ratio of the Gross enrolment ratio (%) in Secondary schools in Kazakhstan to that in Kenya?
Give a very brief answer. 1.17. What is the ratio of the Gross enrolment ratio (%) of Tertiary schools in Kazakhstan to that in Kenya?
Your answer should be compact. 0.41. What is the difference between the highest and the second highest Gross enrolment ratio (%) of Pre-primary schools?
Your answer should be compact. 15.08. What is the difference between the highest and the second highest Gross enrolment ratio (%) in Primary schools?
Provide a short and direct response. 18.19. What is the difference between the highest and the second highest Gross enrolment ratio (%) of Secondary schools?
Your answer should be compact. 4.67. What is the difference between the highest and the second highest Gross enrolment ratio (%) of Tertiary schools?
Give a very brief answer. 8. What is the difference between the highest and the lowest Gross enrolment ratio (%) in Pre-primary schools?
Offer a very short reply. 85.98. What is the difference between the highest and the lowest Gross enrolment ratio (%) of Primary schools?
Ensure brevity in your answer.  83.71. What is the difference between the highest and the lowest Gross enrolment ratio (%) in Secondary schools?
Provide a short and direct response. 73.53. What is the difference between the highest and the lowest Gross enrolment ratio (%) of Tertiary schools?
Give a very brief answer. 22.24. 